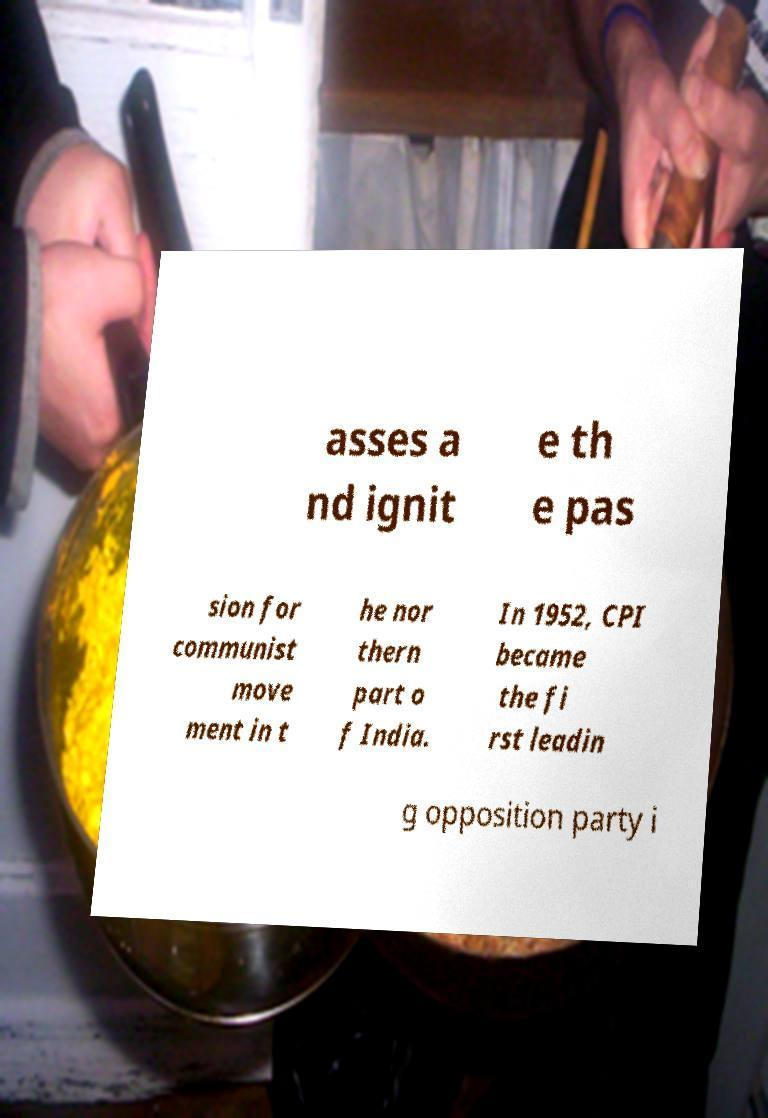Please read and relay the text visible in this image. What does it say? asses a nd ignit e th e pas sion for communist move ment in t he nor thern part o f India. In 1952, CPI became the fi rst leadin g opposition party i 